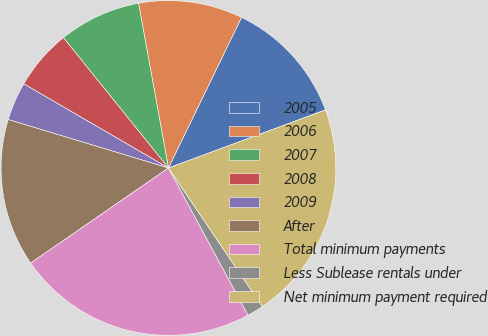Convert chart to OTSL. <chart><loc_0><loc_0><loc_500><loc_500><pie_chart><fcel>2005<fcel>2006<fcel>2007<fcel>2008<fcel>2009<fcel>After<fcel>Total minimum payments<fcel>Less Sublease rentals under<fcel>Net minimum payment required<nl><fcel>12.17%<fcel>10.05%<fcel>7.94%<fcel>5.82%<fcel>3.71%<fcel>14.29%<fcel>23.27%<fcel>1.59%<fcel>21.16%<nl></chart> 